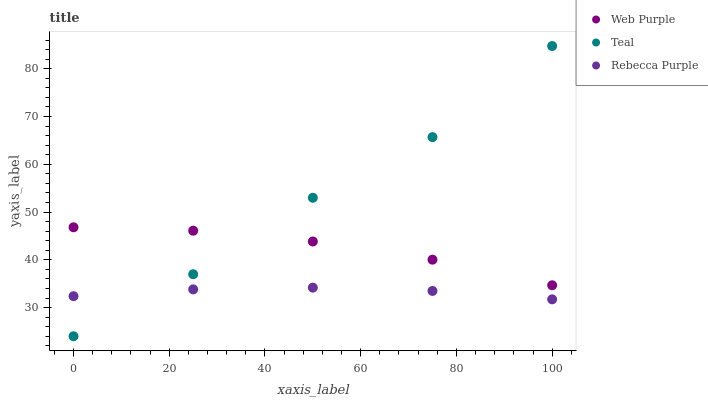Does Rebecca Purple have the minimum area under the curve?
Answer yes or no. Yes. Does Teal have the maximum area under the curve?
Answer yes or no. Yes. Does Teal have the minimum area under the curve?
Answer yes or no. No. Does Rebecca Purple have the maximum area under the curve?
Answer yes or no. No. Is Rebecca Purple the smoothest?
Answer yes or no. Yes. Is Teal the roughest?
Answer yes or no. Yes. Is Teal the smoothest?
Answer yes or no. No. Is Rebecca Purple the roughest?
Answer yes or no. No. Does Teal have the lowest value?
Answer yes or no. Yes. Does Rebecca Purple have the lowest value?
Answer yes or no. No. Does Teal have the highest value?
Answer yes or no. Yes. Does Rebecca Purple have the highest value?
Answer yes or no. No. Is Rebecca Purple less than Web Purple?
Answer yes or no. Yes. Is Web Purple greater than Rebecca Purple?
Answer yes or no. Yes. Does Rebecca Purple intersect Teal?
Answer yes or no. Yes. Is Rebecca Purple less than Teal?
Answer yes or no. No. Is Rebecca Purple greater than Teal?
Answer yes or no. No. Does Rebecca Purple intersect Web Purple?
Answer yes or no. No. 